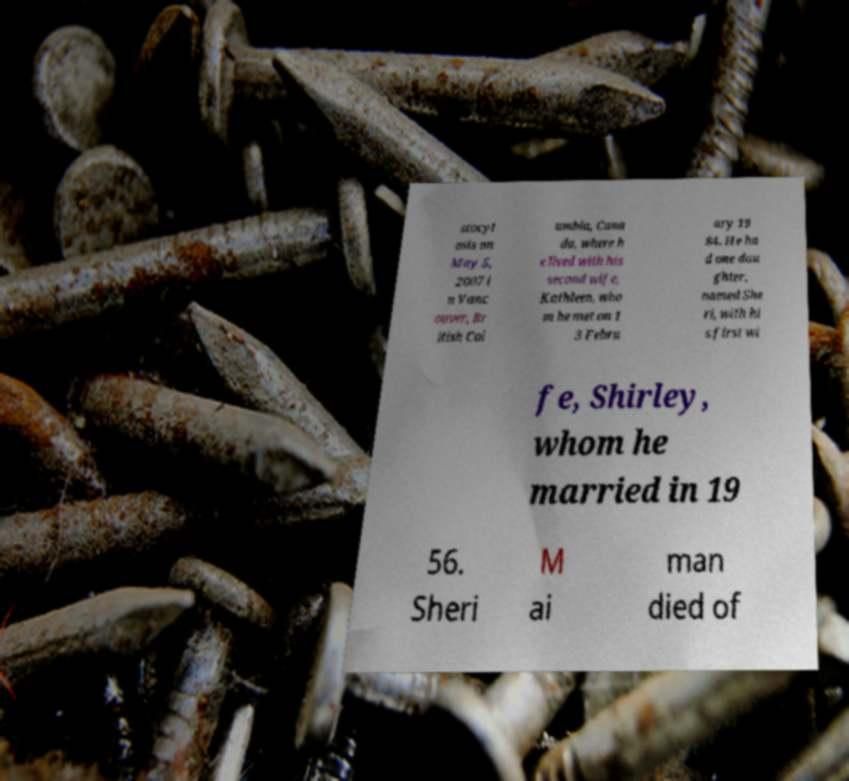For documentation purposes, I need the text within this image transcribed. Could you provide that? stocyt osis on May 5, 2007 i n Vanc ouver, Br itish Col umbia, Cana da, where h e lived with his second wife, Kathleen, who m he met on 1 3 Febru ary 19 84. He ha d one dau ghter, named She ri, with hi s first wi fe, Shirley, whom he married in 19 56. Sheri M ai man died of 